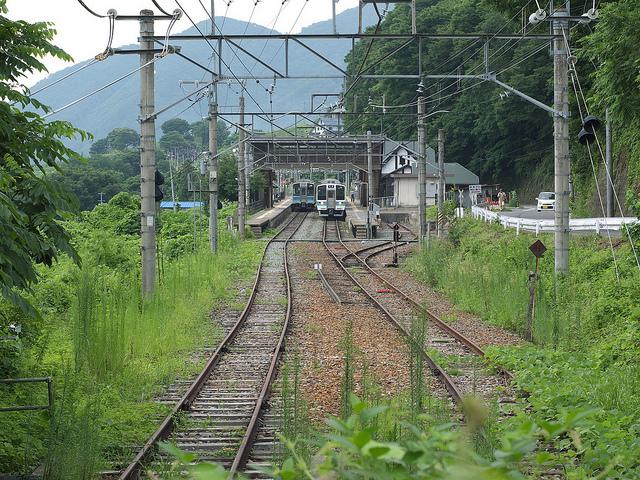What color is the car?
Concise answer only. White. How many trains can be seen?
Short answer required. 2. What color are the tall trees on the left?
Be succinct. Green. 